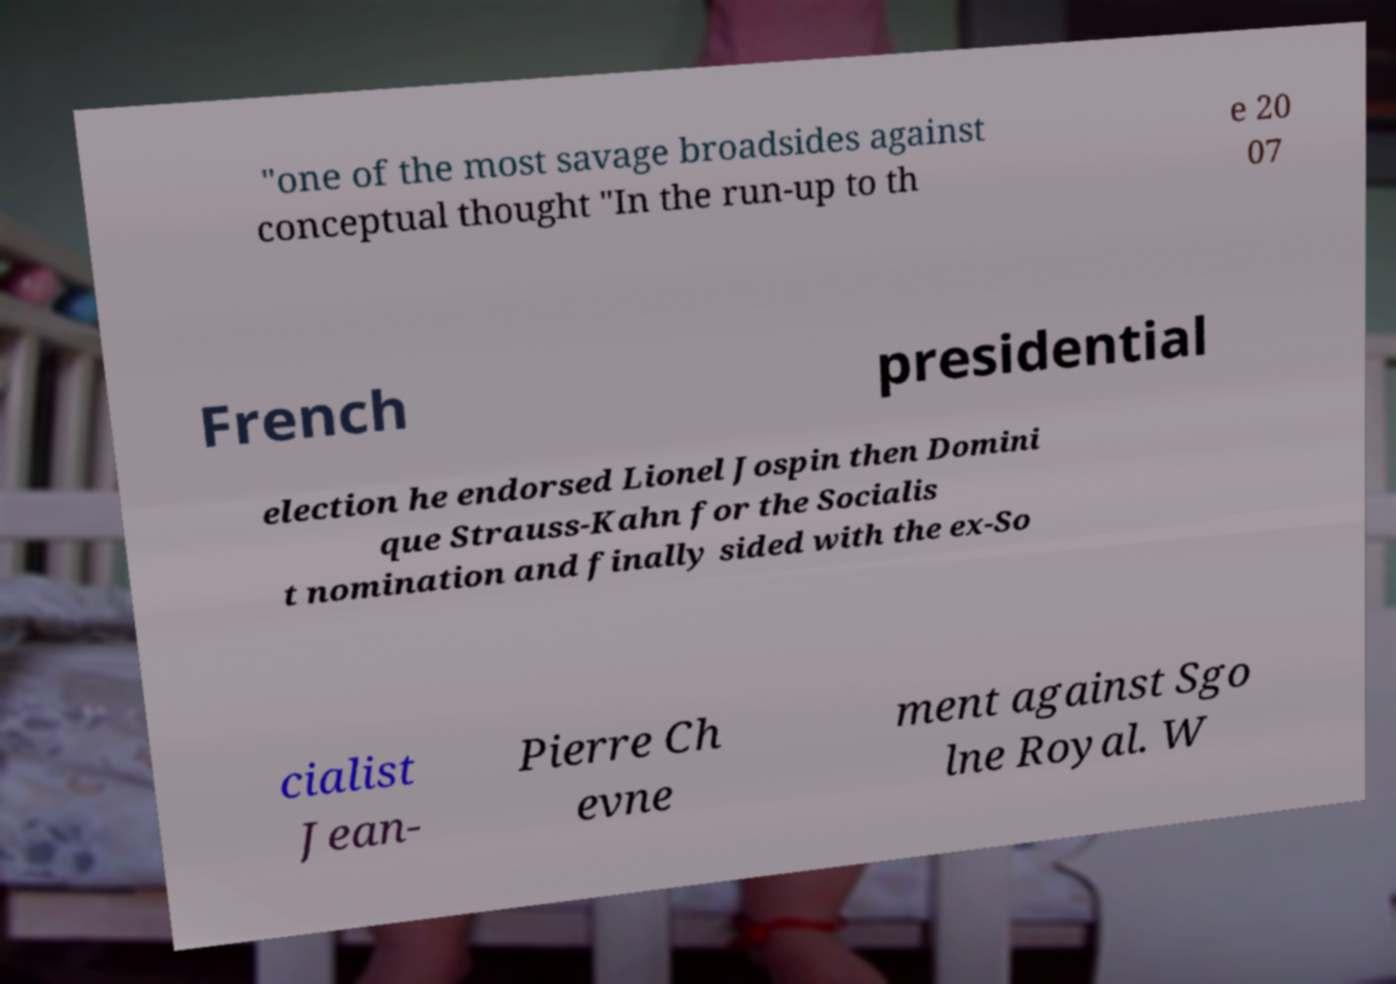Can you accurately transcribe the text from the provided image for me? "one of the most savage broadsides against conceptual thought "In the run-up to th e 20 07 French presidential election he endorsed Lionel Jospin then Domini que Strauss-Kahn for the Socialis t nomination and finally sided with the ex-So cialist Jean- Pierre Ch evne ment against Sgo lne Royal. W 